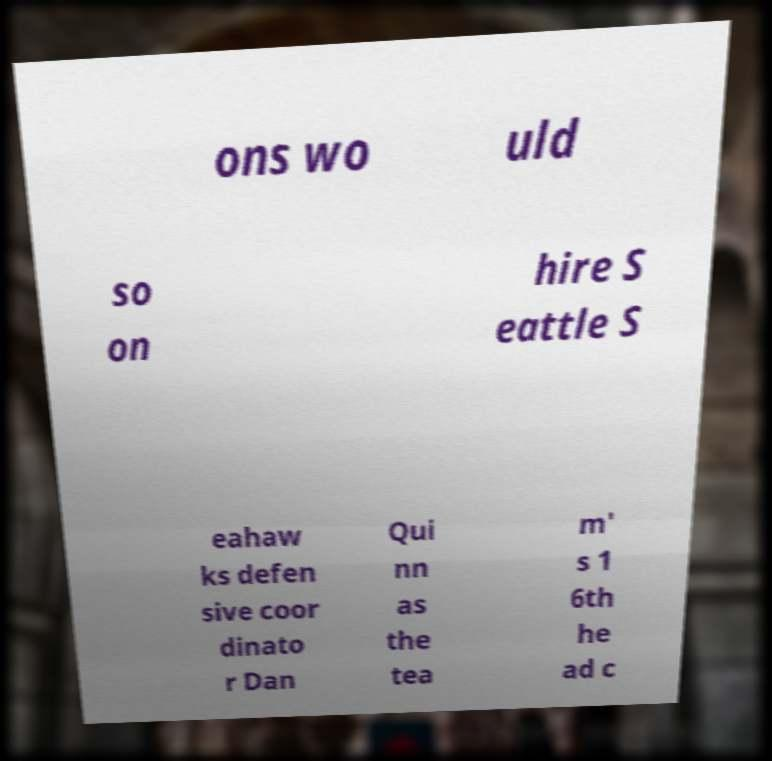Could you assist in decoding the text presented in this image and type it out clearly? ons wo uld so on hire S eattle S eahaw ks defen sive coor dinato r Dan Qui nn as the tea m' s 1 6th he ad c 